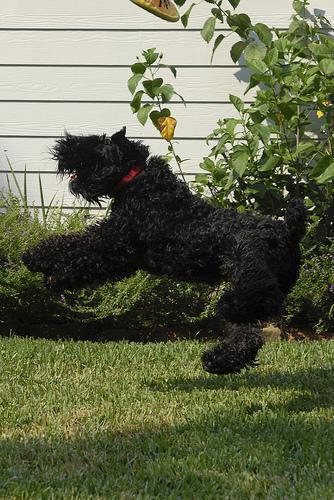How many dogs are shown?
Give a very brief answer. 1. 